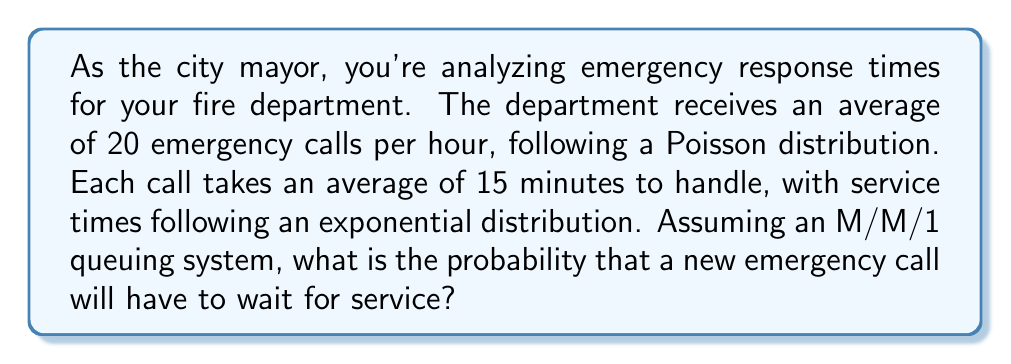Teach me how to tackle this problem. To solve this problem, we'll use queuing theory, specifically the M/M/1 model. Let's break it down step-by-step:

1. Identify the parameters:
   - Arrival rate (λ): 20 calls per hour
   - Service rate (μ): 4 calls per hour (since each call takes 15 minutes on average)

2. Calculate the utilization factor (ρ):
   $$\rho = \frac{\lambda}{\mu} = \frac{20}{4} = 5$$

3. In an M/M/1 system, the probability that a new arrival has to wait (P_w) is equal to the utilization factor (ρ) when ρ < 1. However, in this case, ρ > 1, which indicates an unstable system.

4. When ρ > 1, the queue will grow indefinitely, and the probability of waiting approaches 1 as time goes on.

5. Therefore, in this scenario, the probability that a new emergency call will have to wait for service is effectively 1 (or 100%).

This result suggests that the current system is overloaded and cannot handle the incoming call volume efficiently. As the city mayor, you may want to consider increasing the number of servers (e.g., fire trucks or dispatchers) to improve response times and create a stable system.
Answer: The probability that a new emergency call will have to wait for service is 1 (or 100%). 